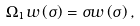Convert formula to latex. <formula><loc_0><loc_0><loc_500><loc_500>\Omega _ { 1 } w \left ( \sigma \right ) = \sigma w \left ( \sigma \right ) ,</formula> 